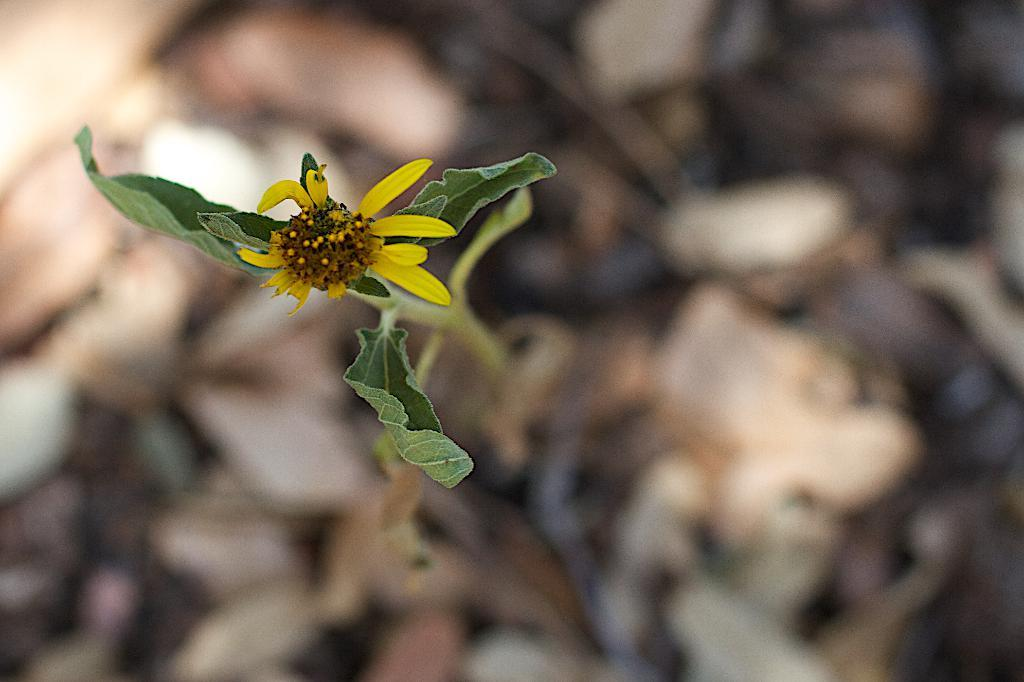What is the main subject of the image? The main subject of the image is a flower. What color is the flower? The flower is yellow in color. Are there any other parts of the plant visible in the image? Yes, there are leaves in the image. What type of drug is being sold on the stage in the image? There is no stage, drug, or any indication of a sale in the image. The image only features a yellow flower and some leaves. 